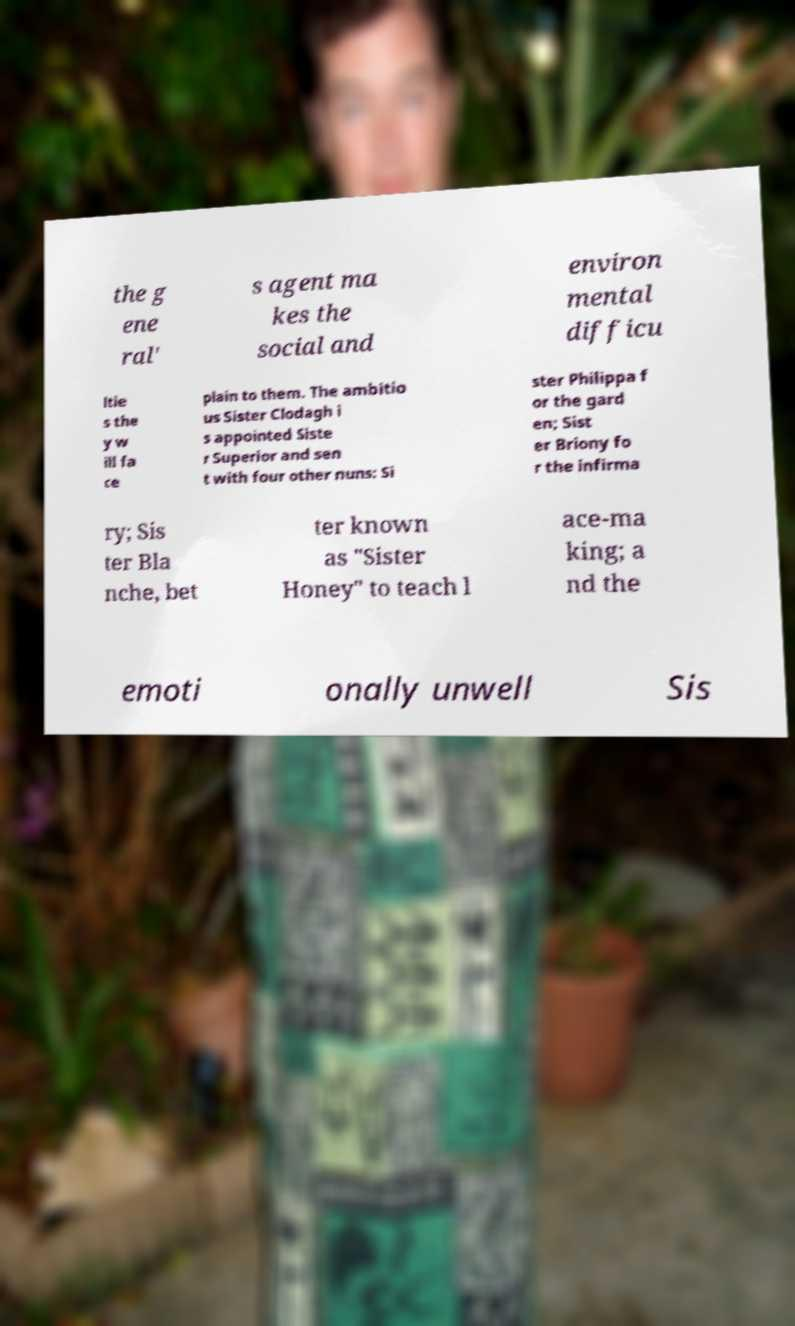For documentation purposes, I need the text within this image transcribed. Could you provide that? the g ene ral' s agent ma kes the social and environ mental difficu ltie s the y w ill fa ce plain to them. The ambitio us Sister Clodagh i s appointed Siste r Superior and sen t with four other nuns: Si ster Philippa f or the gard en; Sist er Briony fo r the infirma ry; Sis ter Bla nche, bet ter known as "Sister Honey" to teach l ace-ma king; a nd the emoti onally unwell Sis 